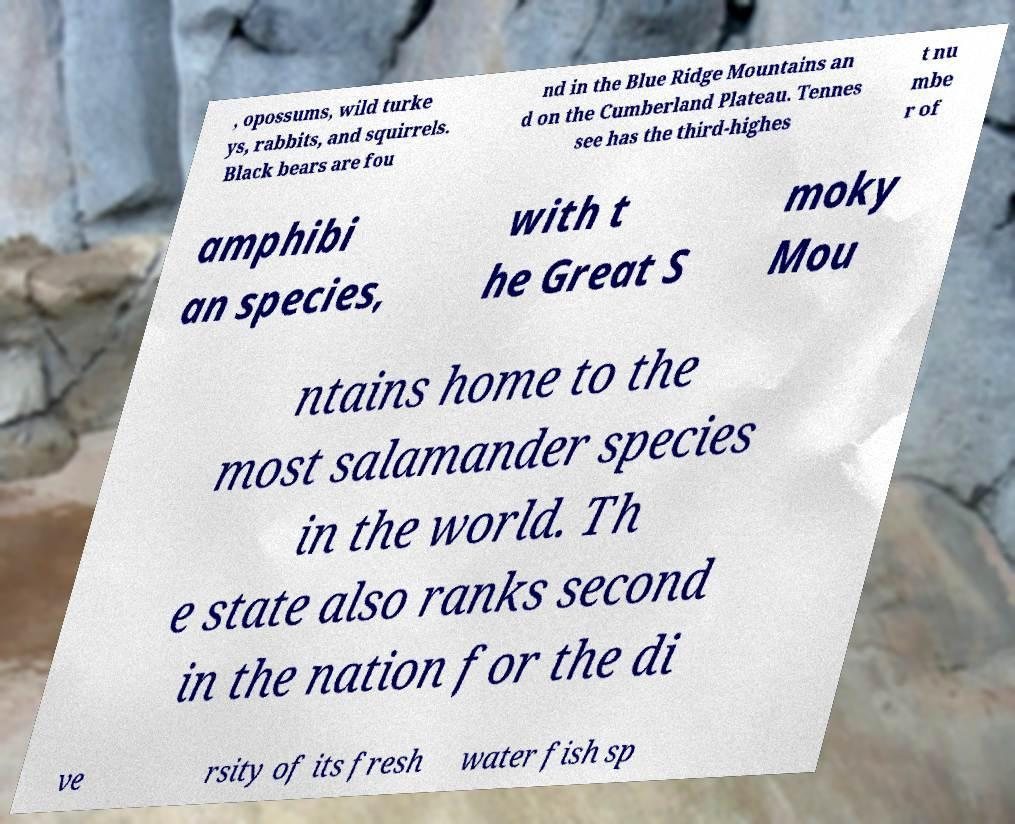Can you read and provide the text displayed in the image?This photo seems to have some interesting text. Can you extract and type it out for me? , opossums, wild turke ys, rabbits, and squirrels. Black bears are fou nd in the Blue Ridge Mountains an d on the Cumberland Plateau. Tennes see has the third-highes t nu mbe r of amphibi an species, with t he Great S moky Mou ntains home to the most salamander species in the world. Th e state also ranks second in the nation for the di ve rsity of its fresh water fish sp 